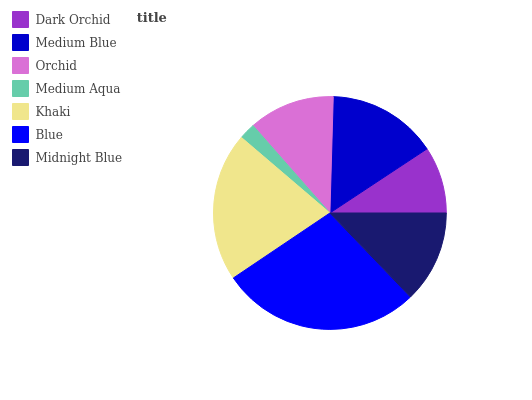Is Medium Aqua the minimum?
Answer yes or no. Yes. Is Blue the maximum?
Answer yes or no. Yes. Is Medium Blue the minimum?
Answer yes or no. No. Is Medium Blue the maximum?
Answer yes or no. No. Is Medium Blue greater than Dark Orchid?
Answer yes or no. Yes. Is Dark Orchid less than Medium Blue?
Answer yes or no. Yes. Is Dark Orchid greater than Medium Blue?
Answer yes or no. No. Is Medium Blue less than Dark Orchid?
Answer yes or no. No. Is Midnight Blue the high median?
Answer yes or no. Yes. Is Midnight Blue the low median?
Answer yes or no. Yes. Is Blue the high median?
Answer yes or no. No. Is Orchid the low median?
Answer yes or no. No. 